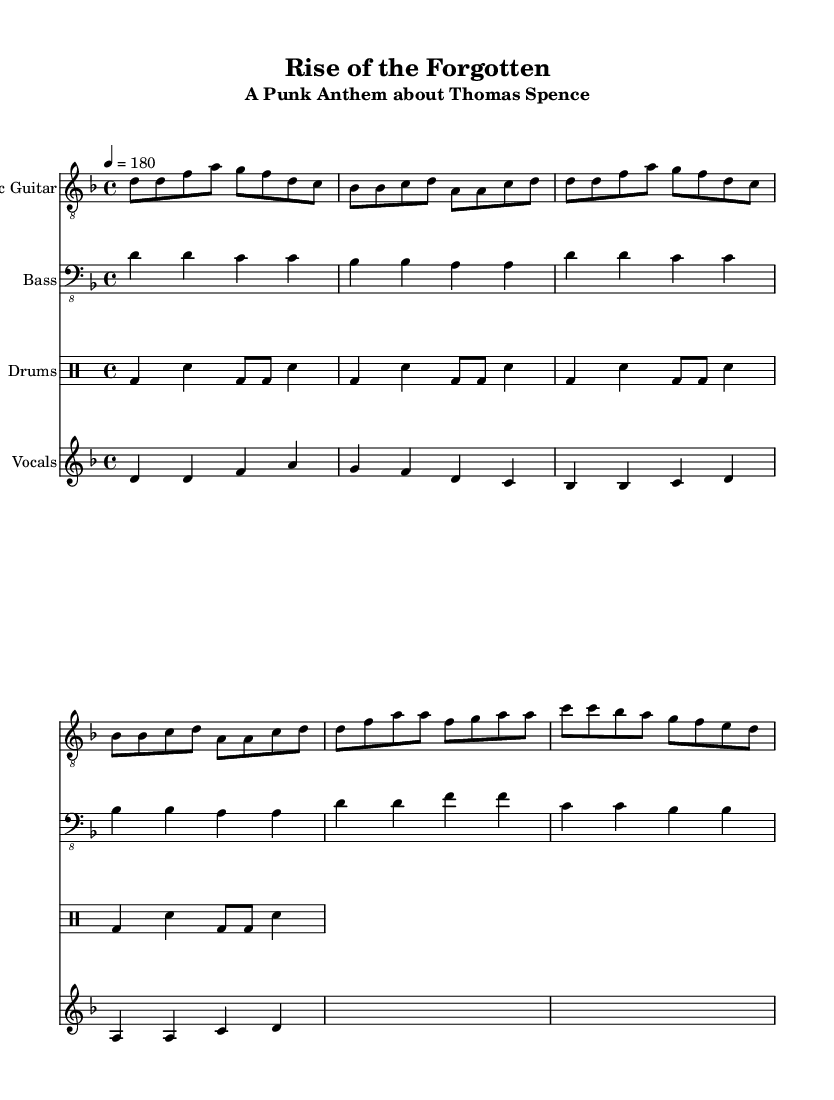What is the key signature of this music? The key signature is D minor, which is indicated by one flat (B flat) on the staff.
Answer: D minor What is the time signature of this music? The time signature is 4/4, as shown at the beginning of the score. Each measure has four beats.
Answer: 4/4 What is the tempo marking for this piece? The tempo marking is quarter note equals 180, indicating a fast-paced performance.
Answer: 180 How many measures are in the verse section? The verse section has four measures, as counted in the provided electric guitar and bass guitar parts.
Answer: 4 What type of beat does the drums part follow? The drums part follows a basic punk beat, characterized by the alternating bass and snare hits creating a driving rhythm.
Answer: Punk beat What instruments are present in this score? The score contains an electric guitar, bass guitar, drums, and vocals, as indicated by their respective staff labels.
Answer: Electric guitar, bass, drums, vocals What refrain lines repeat in the chorus? The phrase "Rise up, forgotten hero" is repeated in the chorus, highlighting the main message of the anthem.
Answer: Rise up, forgotten hero 